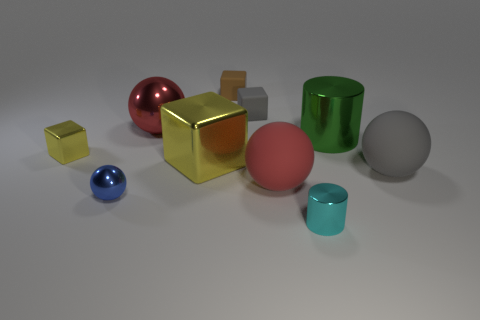Do the red matte ball and the cylinder in front of the large green cylinder have the same size?
Give a very brief answer. No. There is a metal cylinder to the left of the big metallic thing on the right side of the tiny shiny thing that is in front of the tiny blue metal sphere; what size is it?
Offer a terse response. Small. What number of metal objects are either tiny green balls or large gray things?
Ensure brevity in your answer.  0. The tiny metallic object on the right side of the red shiny ball is what color?
Offer a terse response. Cyan. There is a yellow object that is the same size as the cyan shiny thing; what shape is it?
Ensure brevity in your answer.  Cube. There is a large shiny cylinder; does it have the same color as the metallic ball that is in front of the green object?
Ensure brevity in your answer.  No. What number of objects are either rubber objects behind the large gray object or matte things that are behind the small yellow shiny cube?
Provide a succinct answer. 2. There is a gray thing that is the same size as the cyan metallic cylinder; what is its material?
Your answer should be compact. Rubber. What number of other objects are there of the same material as the brown block?
Your answer should be compact. 3. There is a large red object that is left of the tiny brown cube; does it have the same shape as the tiny shiny thing that is behind the small ball?
Provide a short and direct response. No. 